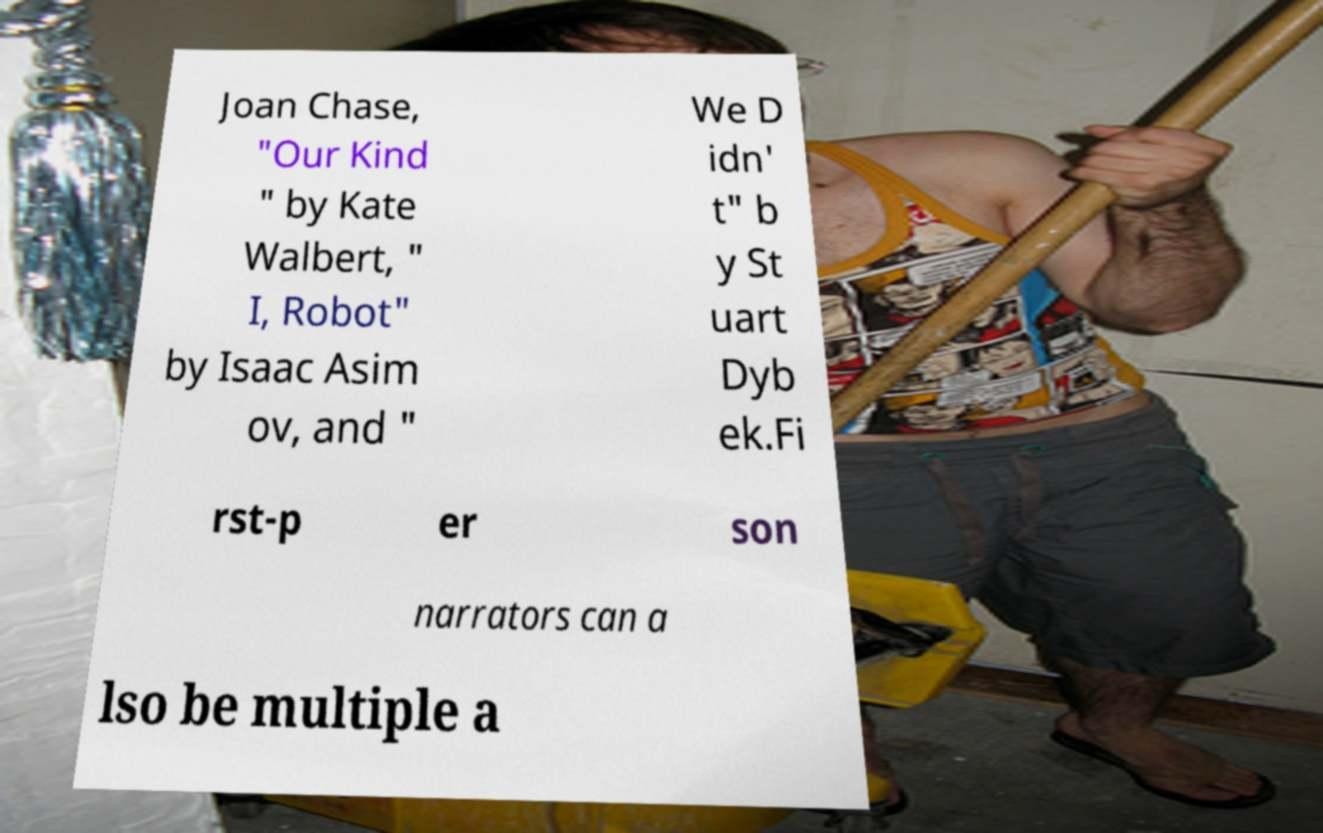I need the written content from this picture converted into text. Can you do that? Joan Chase, "Our Kind " by Kate Walbert, " I, Robot" by Isaac Asim ov, and " We D idn' t" b y St uart Dyb ek.Fi rst-p er son narrators can a lso be multiple a 